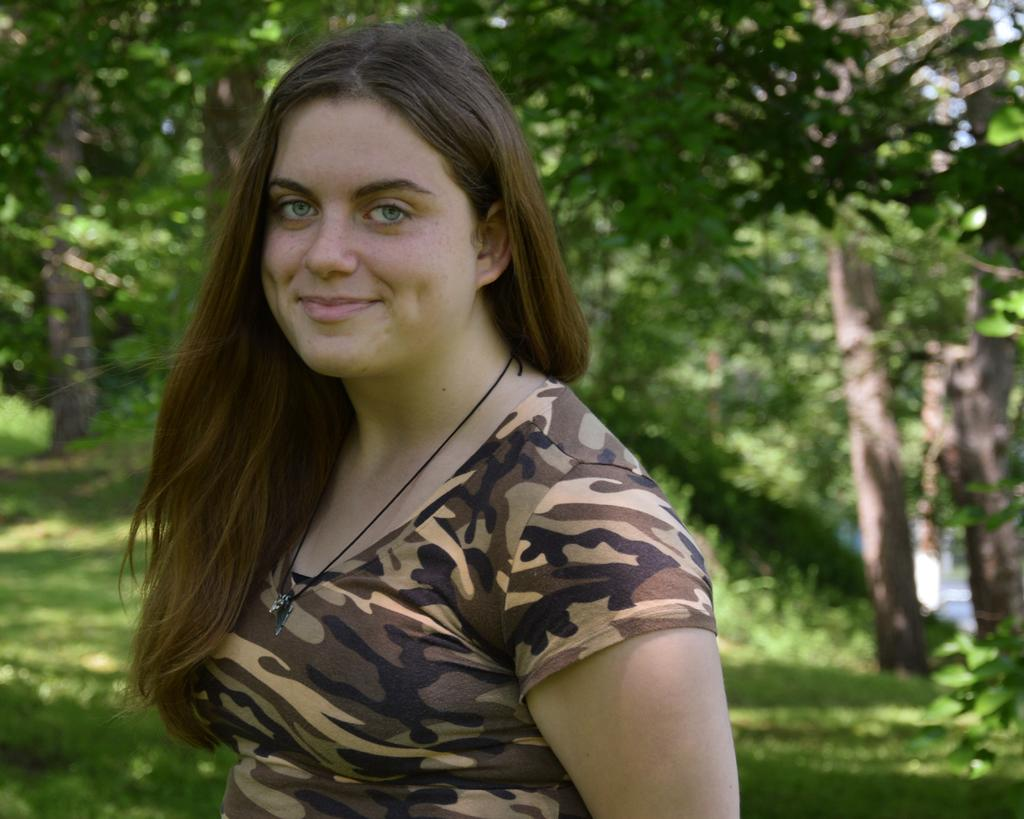Who is present in the image? There is a woman in the image. What is the woman doing in the image? The woman is standing in the image. What is the woman's facial expression in the image? The woman is smiling in the image. What can be seen in the background of the image? There are green color trees in the background of the image. What type of vest is the woman wearing in the image? There is no vest visible in the image; the woman is not wearing any clothing item mentioned in the facts. 